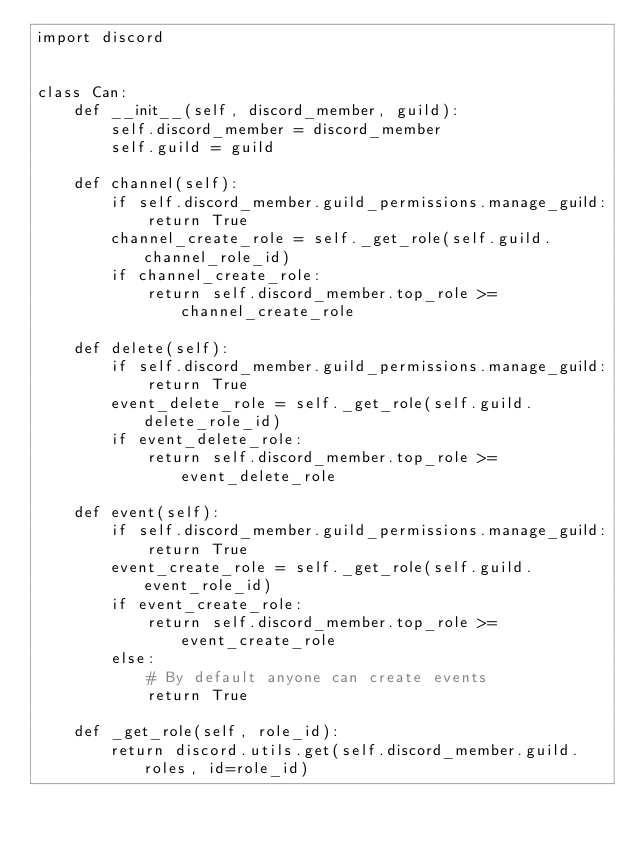Convert code to text. <code><loc_0><loc_0><loc_500><loc_500><_Python_>import discord


class Can:
    def __init__(self, discord_member, guild):
        self.discord_member = discord_member
        self.guild = guild

    def channel(self):
        if self.discord_member.guild_permissions.manage_guild:
            return True
        channel_create_role = self._get_role(self.guild.channel_role_id)
        if channel_create_role:
            return self.discord_member.top_role >= channel_create_role

    def delete(self):
        if self.discord_member.guild_permissions.manage_guild:
            return True
        event_delete_role = self._get_role(self.guild.delete_role_id)
        if event_delete_role:
            return self.discord_member.top_role >= event_delete_role

    def event(self):
        if self.discord_member.guild_permissions.manage_guild:
            return True
        event_create_role = self._get_role(self.guild.event_role_id)
        if event_create_role:
            return self.discord_member.top_role >= event_create_role
        else:
            # By default anyone can create events
            return True

    def _get_role(self, role_id):
        return discord.utils.get(self.discord_member.guild.roles, id=role_id)
</code> 